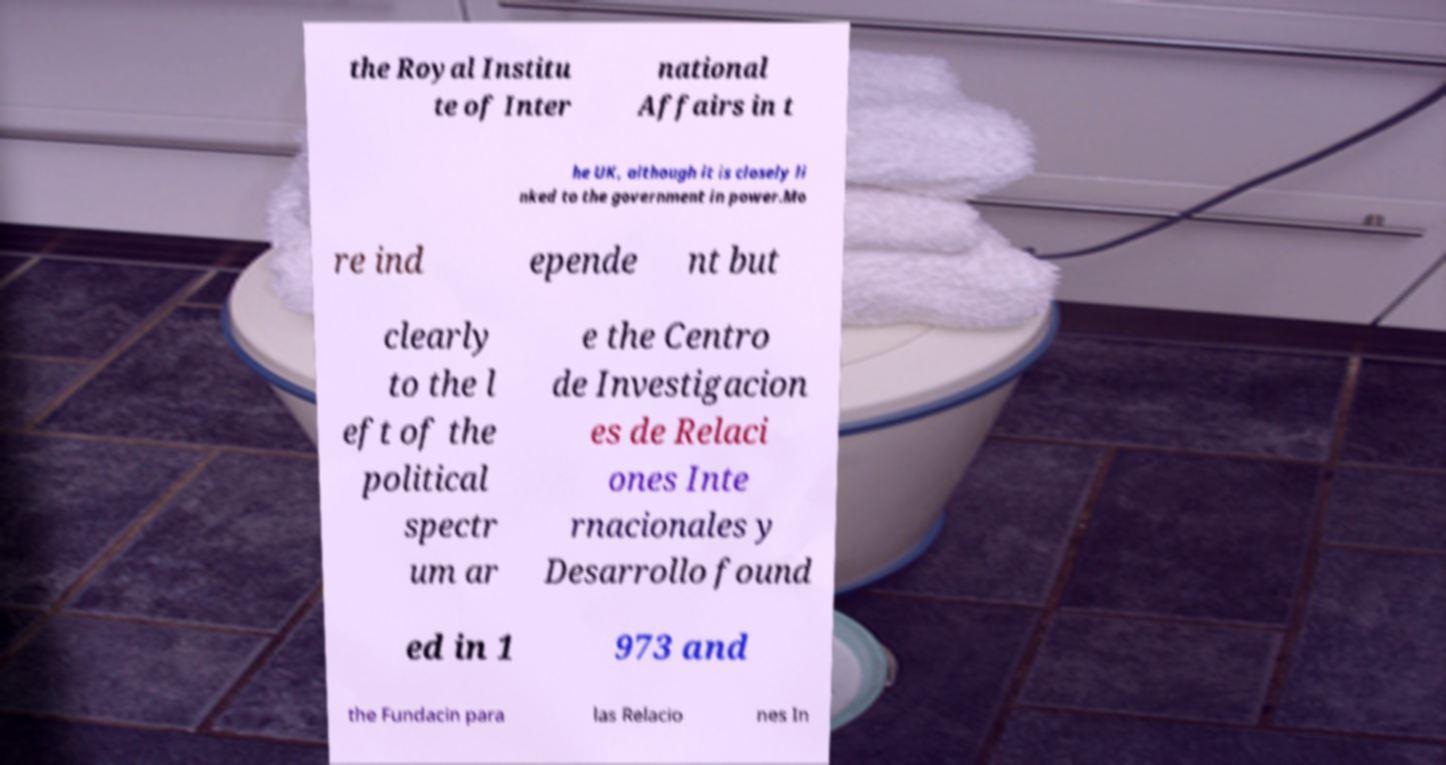There's text embedded in this image that I need extracted. Can you transcribe it verbatim? the Royal Institu te of Inter national Affairs in t he UK, although it is closely li nked to the government in power.Mo re ind epende nt but clearly to the l eft of the political spectr um ar e the Centro de Investigacion es de Relaci ones Inte rnacionales y Desarrollo found ed in 1 973 and the Fundacin para las Relacio nes In 